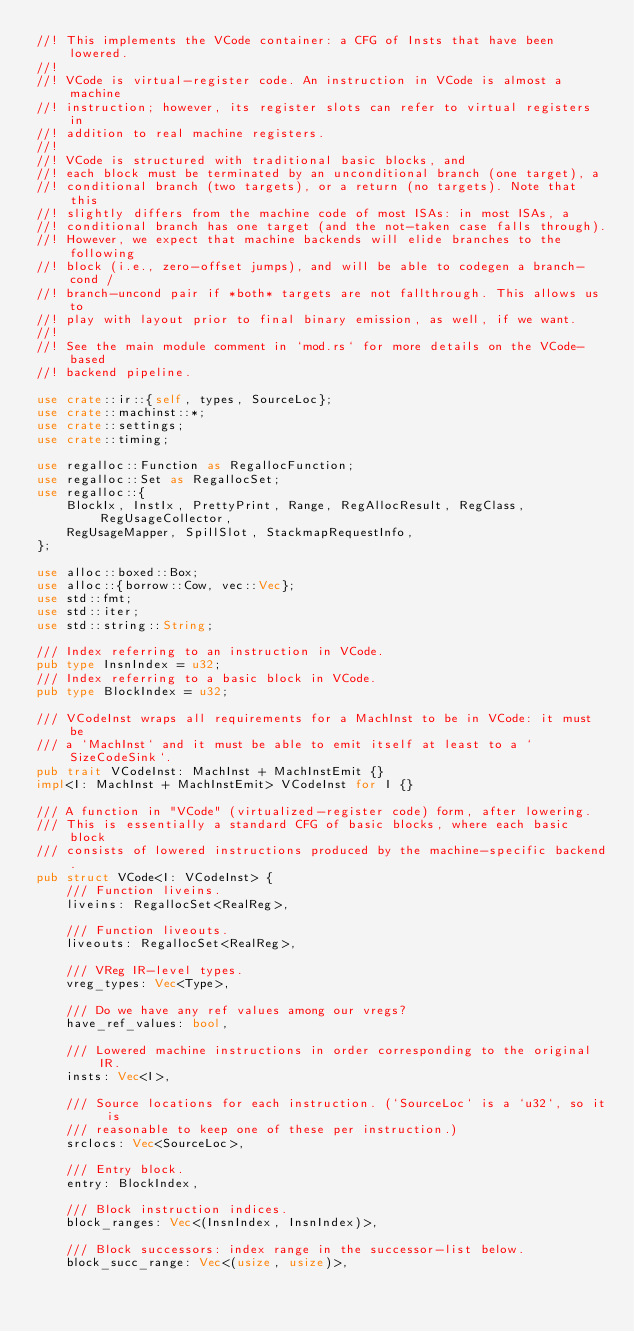Convert code to text. <code><loc_0><loc_0><loc_500><loc_500><_Rust_>//! This implements the VCode container: a CFG of Insts that have been lowered.
//!
//! VCode is virtual-register code. An instruction in VCode is almost a machine
//! instruction; however, its register slots can refer to virtual registers in
//! addition to real machine registers.
//!
//! VCode is structured with traditional basic blocks, and
//! each block must be terminated by an unconditional branch (one target), a
//! conditional branch (two targets), or a return (no targets). Note that this
//! slightly differs from the machine code of most ISAs: in most ISAs, a
//! conditional branch has one target (and the not-taken case falls through).
//! However, we expect that machine backends will elide branches to the following
//! block (i.e., zero-offset jumps), and will be able to codegen a branch-cond /
//! branch-uncond pair if *both* targets are not fallthrough. This allows us to
//! play with layout prior to final binary emission, as well, if we want.
//!
//! See the main module comment in `mod.rs` for more details on the VCode-based
//! backend pipeline.

use crate::ir::{self, types, SourceLoc};
use crate::machinst::*;
use crate::settings;
use crate::timing;

use regalloc::Function as RegallocFunction;
use regalloc::Set as RegallocSet;
use regalloc::{
    BlockIx, InstIx, PrettyPrint, Range, RegAllocResult, RegClass, RegUsageCollector,
    RegUsageMapper, SpillSlot, StackmapRequestInfo,
};

use alloc::boxed::Box;
use alloc::{borrow::Cow, vec::Vec};
use std::fmt;
use std::iter;
use std::string::String;

/// Index referring to an instruction in VCode.
pub type InsnIndex = u32;
/// Index referring to a basic block in VCode.
pub type BlockIndex = u32;

/// VCodeInst wraps all requirements for a MachInst to be in VCode: it must be
/// a `MachInst` and it must be able to emit itself at least to a `SizeCodeSink`.
pub trait VCodeInst: MachInst + MachInstEmit {}
impl<I: MachInst + MachInstEmit> VCodeInst for I {}

/// A function in "VCode" (virtualized-register code) form, after lowering.
/// This is essentially a standard CFG of basic blocks, where each basic block
/// consists of lowered instructions produced by the machine-specific backend.
pub struct VCode<I: VCodeInst> {
    /// Function liveins.
    liveins: RegallocSet<RealReg>,

    /// Function liveouts.
    liveouts: RegallocSet<RealReg>,

    /// VReg IR-level types.
    vreg_types: Vec<Type>,

    /// Do we have any ref values among our vregs?
    have_ref_values: bool,

    /// Lowered machine instructions in order corresponding to the original IR.
    insts: Vec<I>,

    /// Source locations for each instruction. (`SourceLoc` is a `u32`, so it is
    /// reasonable to keep one of these per instruction.)
    srclocs: Vec<SourceLoc>,

    /// Entry block.
    entry: BlockIndex,

    /// Block instruction indices.
    block_ranges: Vec<(InsnIndex, InsnIndex)>,

    /// Block successors: index range in the successor-list below.
    block_succ_range: Vec<(usize, usize)>,
</code> 